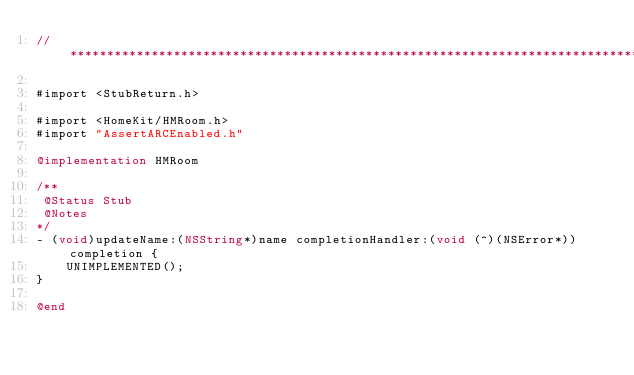Convert code to text. <code><loc_0><loc_0><loc_500><loc_500><_ObjectiveC_>//******************************************************************************

#import <StubReturn.h>

#import <HomeKit/HMRoom.h>
#import "AssertARCEnabled.h"

@implementation HMRoom

/**
 @Status Stub
 @Notes
*/
- (void)updateName:(NSString*)name completionHandler:(void (^)(NSError*))completion {
    UNIMPLEMENTED();
}

@end
</code> 